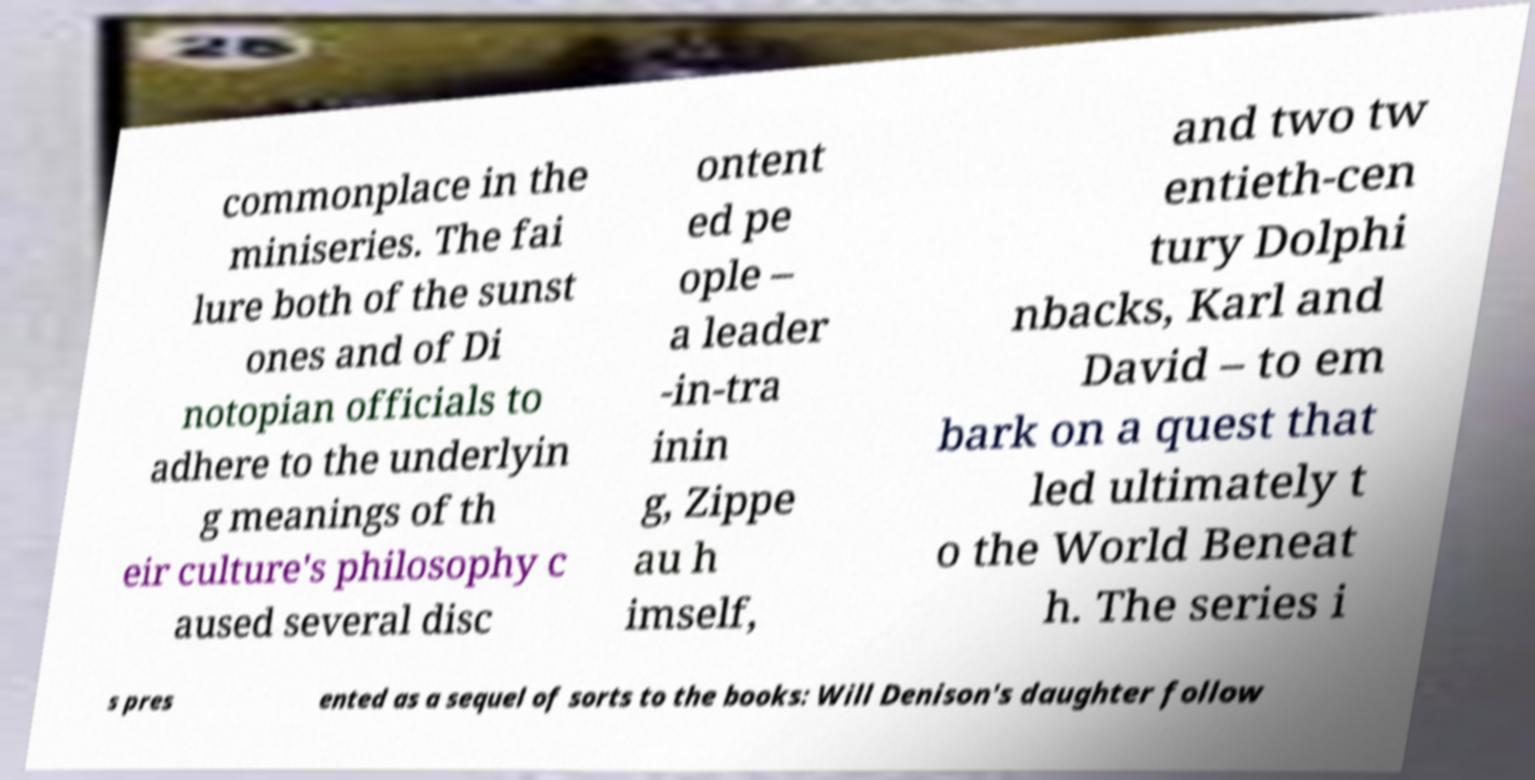There's text embedded in this image that I need extracted. Can you transcribe it verbatim? commonplace in the miniseries. The fai lure both of the sunst ones and of Di notopian officials to adhere to the underlyin g meanings of th eir culture's philosophy c aused several disc ontent ed pe ople – a leader -in-tra inin g, Zippe au h imself, and two tw entieth-cen tury Dolphi nbacks, Karl and David – to em bark on a quest that led ultimately t o the World Beneat h. The series i s pres ented as a sequel of sorts to the books: Will Denison's daughter follow 